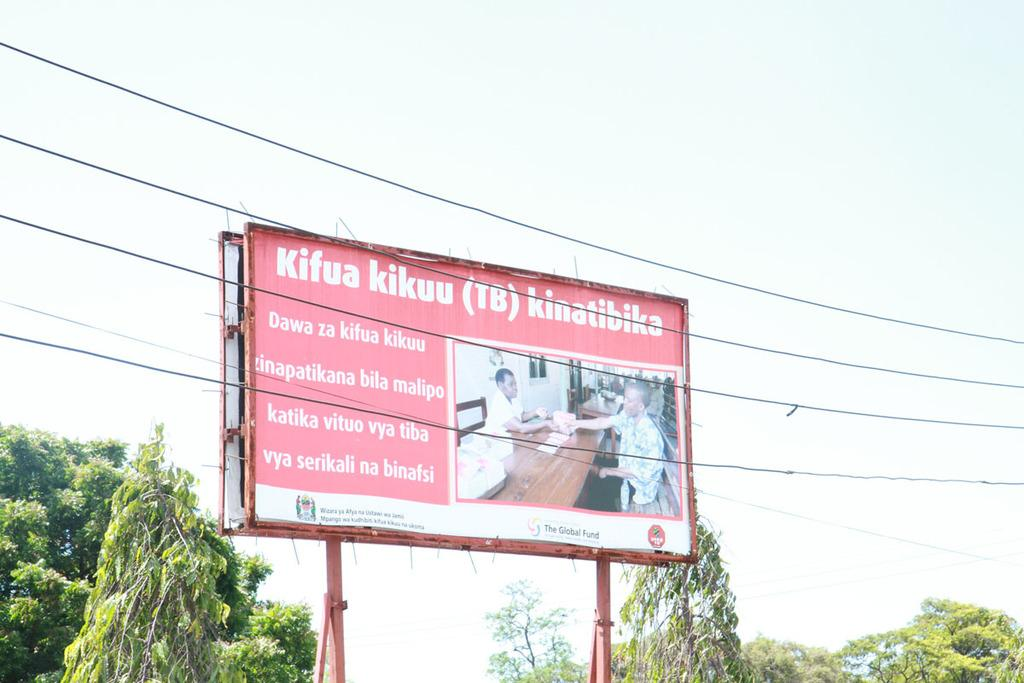What is the main object in the image? There is a board in the image. What else can be seen in the image besides the board? There is a wire and trees visible in the image. What is visible in the background of the image? The sky is visible in the image. How does the pail help to regulate the temperature in the image? There is no pail present in the image, so it cannot help regulate any temperature. 